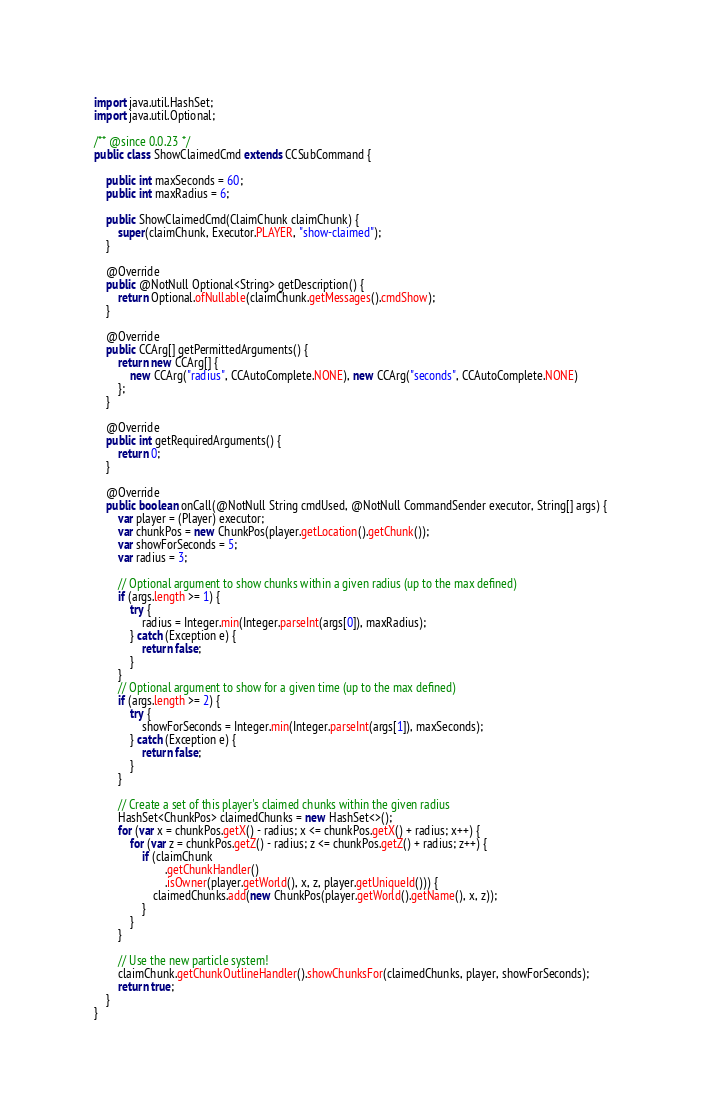Convert code to text. <code><loc_0><loc_0><loc_500><loc_500><_Java_>import java.util.HashSet;
import java.util.Optional;

/** @since 0.0.23 */
public class ShowClaimedCmd extends CCSubCommand {

    public int maxSeconds = 60;
    public int maxRadius = 6;

    public ShowClaimedCmd(ClaimChunk claimChunk) {
        super(claimChunk, Executor.PLAYER, "show-claimed");
    }

    @Override
    public @NotNull Optional<String> getDescription() {
        return Optional.ofNullable(claimChunk.getMessages().cmdShow);
    }

    @Override
    public CCArg[] getPermittedArguments() {
        return new CCArg[] {
            new CCArg("radius", CCAutoComplete.NONE), new CCArg("seconds", CCAutoComplete.NONE)
        };
    }

    @Override
    public int getRequiredArguments() {
        return 0;
    }

    @Override
    public boolean onCall(@NotNull String cmdUsed, @NotNull CommandSender executor, String[] args) {
        var player = (Player) executor;
        var chunkPos = new ChunkPos(player.getLocation().getChunk());
        var showForSeconds = 5;
        var radius = 3;

        // Optional argument to show chunks within a given radius (up to the max defined)
        if (args.length >= 1) {
            try {
                radius = Integer.min(Integer.parseInt(args[0]), maxRadius);
            } catch (Exception e) {
                return false;
            }
        }
        // Optional argument to show for a given time (up to the max defined)
        if (args.length >= 2) {
            try {
                showForSeconds = Integer.min(Integer.parseInt(args[1]), maxSeconds);
            } catch (Exception e) {
                return false;
            }
        }

        // Create a set of this player's claimed chunks within the given radius
        HashSet<ChunkPos> claimedChunks = new HashSet<>();
        for (var x = chunkPos.getX() - radius; x <= chunkPos.getX() + radius; x++) {
            for (var z = chunkPos.getZ() - radius; z <= chunkPos.getZ() + radius; z++) {
                if (claimChunk
                        .getChunkHandler()
                        .isOwner(player.getWorld(), x, z, player.getUniqueId())) {
                    claimedChunks.add(new ChunkPos(player.getWorld().getName(), x, z));
                }
            }
        }

        // Use the new particle system!
        claimChunk.getChunkOutlineHandler().showChunksFor(claimedChunks, player, showForSeconds);
        return true;
    }
}
</code> 